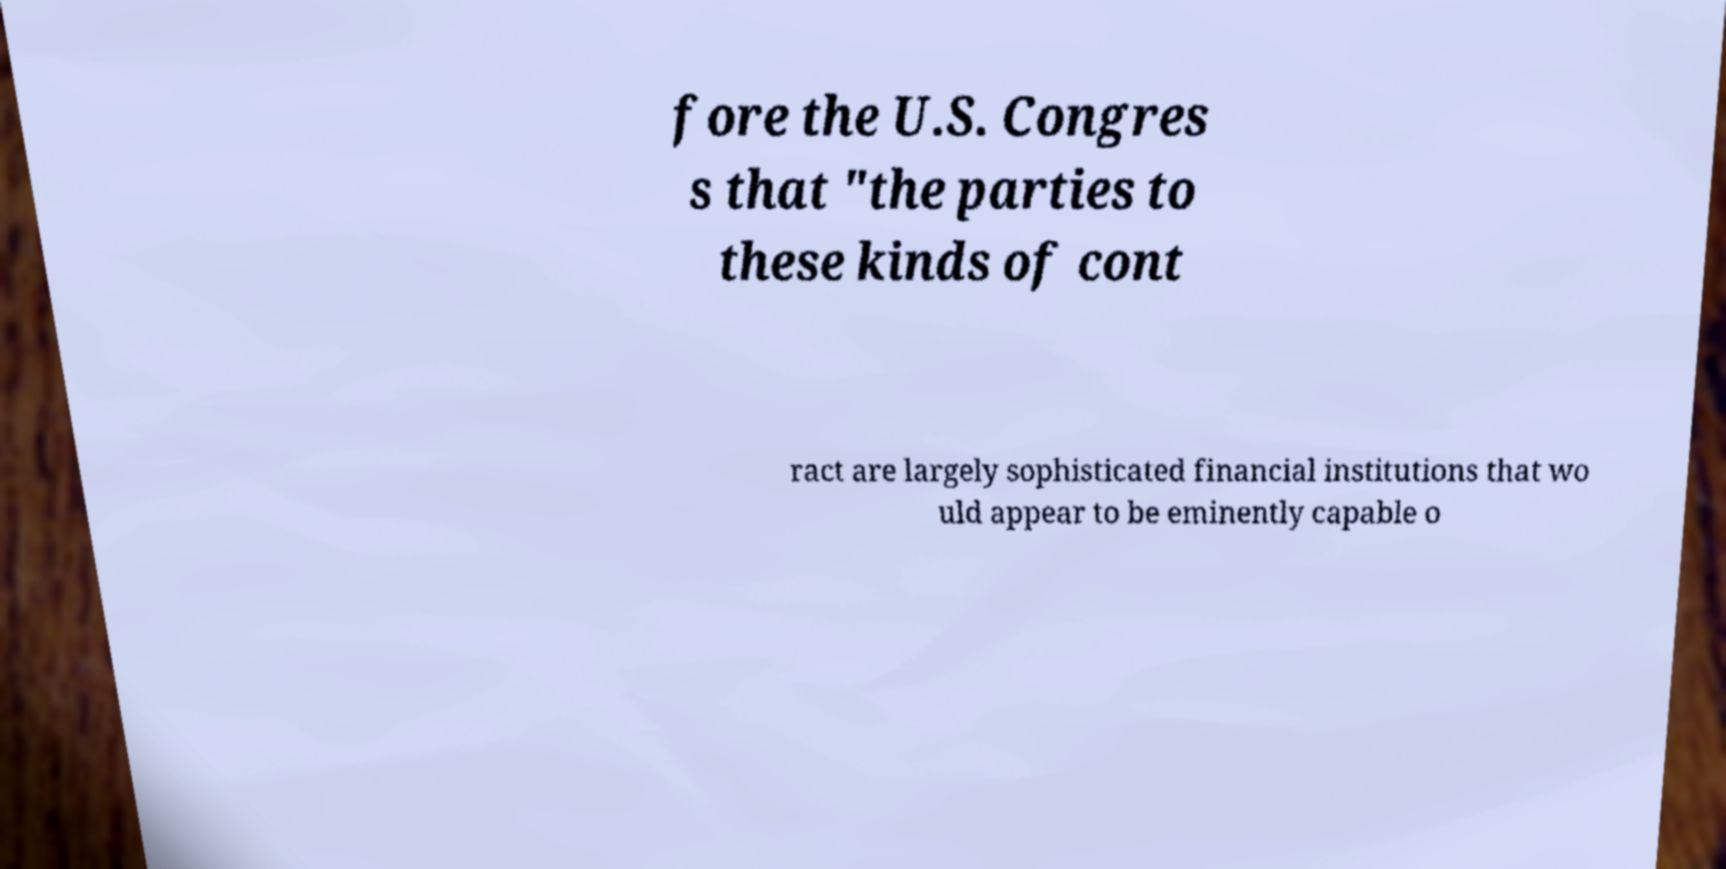There's text embedded in this image that I need extracted. Can you transcribe it verbatim? fore the U.S. Congres s that "the parties to these kinds of cont ract are largely sophisticated financial institutions that wo uld appear to be eminently capable o 